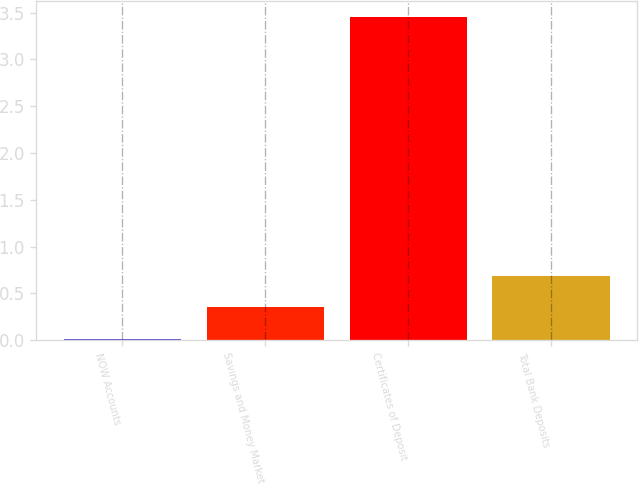Convert chart. <chart><loc_0><loc_0><loc_500><loc_500><bar_chart><fcel>NOW Accounts<fcel>Savings and Money Market<fcel>Certificates of Deposit<fcel>Total Bank Deposits<nl><fcel>0.01<fcel>0.35<fcel>3.45<fcel>0.69<nl></chart> 